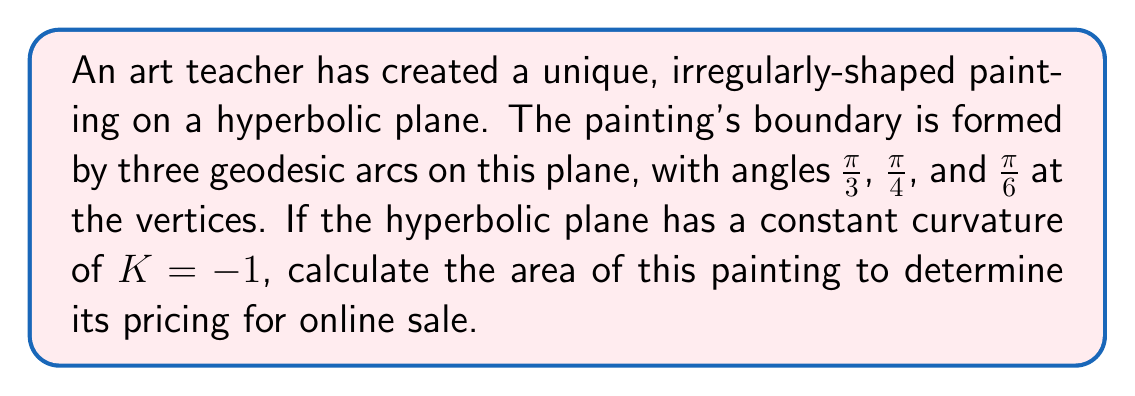Help me with this question. To solve this problem, we'll use the Gauss-Bonnet formula for hyperbolic triangles. The steps are as follows:

1) The Gauss-Bonnet formula for a hyperbolic triangle states:

   $$A = \pi - (\alpha + \beta + \gamma)$$

   where $A$ is the area and $\alpha$, $\beta$, and $\gamma$ are the angles of the triangle.

2) We're given the angles:
   $\alpha = \frac{\pi}{3}$, $\beta = \frac{\pi}{4}$, and $\gamma = \frac{\pi}{6}$

3) Substituting these into the formula:

   $$A = \pi - (\frac{\pi}{3} + \frac{\pi}{4} + \frac{\pi}{6})$$

4) Simplify the right side:
   $$A = \pi - (\frac{4\pi}{12} + \frac{3\pi}{12} + \frac{2\pi}{12})$$
   $$A = \pi - \frac{9\pi}{12}$$

5) Subtract:
   $$A = \frac{12\pi}{12} - \frac{9\pi}{12} = \frac{3\pi}{12} = \frac{\pi}{4}$$

6) Therefore, the area of the painting is $\frac{\pi}{4}$ square units in the hyperbolic plane with $K = -1$.

Note: In a hyperbolic plane with $K = -1$, this area is dimensionless. If needed for pricing, you'd need to convert this to a real-world measurement based on the specific hyperbolic model used.
Answer: $\frac{\pi}{4}$ square units 